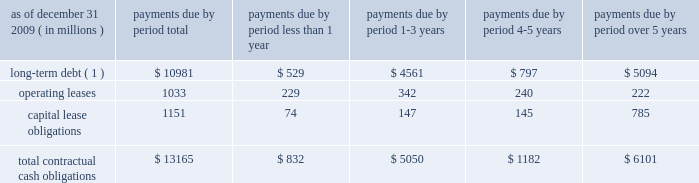We currently maintain a corporate commercial paper program , unrelated to the conduits 2019 asset-backed commercial paper program , under which we can issue up to $ 3 billion with original maturities of up to 270 days from the date of issue .
At december 31 , 2009 , we had $ 2.78 billion of commercial paper outstanding , compared to $ 2.59 billion at december 31 , 2008 .
Additional information about our corporate commercial paper program is provided in note 8 of the notes to consolidated financial statements included under item 8 .
In connection with our participation in the fdic 2019s temporary liquidity guarantee program , or tlgp , in which we elected to participate in december 2008 , the parent company was eligible to issue up to approximately $ 1.67 billion of unsecured senior debt during 2009 , backed by the full faith and credit of the united states .
As of december 31 , 2009 , the parent company 2019s outstanding unsecured senior debt issued under the tlgp was $ 1.5 billion .
Additional information with respect to this outstanding debt is provided in note 9 of the notes to consolidated financial statements included under item 8 .
The guarantee of this outstanding debt under the tlgp expires on april 30 , 2012 , the maturity date of the debt .
State street bank currently has board authority to issue bank notes up to an aggregate of $ 5 billion , and up to $ 1 billion of subordinated bank notes .
In connection with state street bank 2019s participation in the tlgp , in which state street bank elected to participate in december 2008 , state street bank was eligible to issue up to approximately $ 2.48 billion of unsecured senior notes during 2009 , backed by the full faith and credit of the united states .
As of december 31 , 2009 , state street bank 2019s outstanding unsecured senior notes issued under the tlgp , and pursuant to the aforementioned board authority , totaled $ 2.45 billion .
Additional information with respect to these outstanding bank notes is provided in note 9 of the notes to consolidated financial statements included under item 8 .
The guarantee of state street bank 2019s outstanding debt under the tlgp expires on the maturity date of each respective debt issuance , as follows 2014$ 1 billion on march 15 , 2011 , and $ 1.45 billion on september 15 , 2011 .
State street bank currently maintains a line of credit with a financial institution of cad $ 800 million , or approximately $ 761 million as of december 31 , 2009 , to support its canadian securities processing operations .
The line of credit has no stated termination date and is cancelable by either party with prior notice .
As of december 31 , 2009 , no balance was outstanding on this line of credit .
Contractual cash obligations .
( 1 ) long-term debt excludes capital lease obligations ( reported as a separate line item ) and the effect of interest- rate swaps .
Interest payments were calculated at the stated rate with the exception of floating-rate debt , for which payments were calculated using the indexed rate in effect on december 31 , 2009 .
The obligations presented in the table above are recorded in our consolidated statement of condition at december 31 , 2009 , except for interest on long-term debt .
The table does not include obligations which will be settled in cash , primarily in less than one year , such as deposits , federal funds purchased , securities sold under repurchase agreements and other short-term borrowings .
Additional information about deposits , federal funds purchased , securities sold under repurchase agreements and other short-term borrowings is provided in notes 7 and 8 of the notes to consolidated financial statements included under item 8 .
The table does not include obligations related to derivative instruments , because the amounts included in our consolidated statement of condition at december 31 , 2009 related to derivatives do not represent the amounts that may ultimately be paid under the contracts upon settlement .
Additional information about derivative contracts is provided in note 16 of the notes to consolidated financial statements included under item 8 .
We have obligations under pension and other post-retirement benefit plans , more fully described in note 18 of the notes to consolidated financial statements included under item 8 , which are not included in the above table. .
What percent of the total payments are due to be paid off within the first year? 
Computations: (832 / 13165)
Answer: 0.0632. We currently maintain a corporate commercial paper program , unrelated to the conduits 2019 asset-backed commercial paper program , under which we can issue up to $ 3 billion with original maturities of up to 270 days from the date of issue .
At december 31 , 2009 , we had $ 2.78 billion of commercial paper outstanding , compared to $ 2.59 billion at december 31 , 2008 .
Additional information about our corporate commercial paper program is provided in note 8 of the notes to consolidated financial statements included under item 8 .
In connection with our participation in the fdic 2019s temporary liquidity guarantee program , or tlgp , in which we elected to participate in december 2008 , the parent company was eligible to issue up to approximately $ 1.67 billion of unsecured senior debt during 2009 , backed by the full faith and credit of the united states .
As of december 31 , 2009 , the parent company 2019s outstanding unsecured senior debt issued under the tlgp was $ 1.5 billion .
Additional information with respect to this outstanding debt is provided in note 9 of the notes to consolidated financial statements included under item 8 .
The guarantee of this outstanding debt under the tlgp expires on april 30 , 2012 , the maturity date of the debt .
State street bank currently has board authority to issue bank notes up to an aggregate of $ 5 billion , and up to $ 1 billion of subordinated bank notes .
In connection with state street bank 2019s participation in the tlgp , in which state street bank elected to participate in december 2008 , state street bank was eligible to issue up to approximately $ 2.48 billion of unsecured senior notes during 2009 , backed by the full faith and credit of the united states .
As of december 31 , 2009 , state street bank 2019s outstanding unsecured senior notes issued under the tlgp , and pursuant to the aforementioned board authority , totaled $ 2.45 billion .
Additional information with respect to these outstanding bank notes is provided in note 9 of the notes to consolidated financial statements included under item 8 .
The guarantee of state street bank 2019s outstanding debt under the tlgp expires on the maturity date of each respective debt issuance , as follows 2014$ 1 billion on march 15 , 2011 , and $ 1.45 billion on september 15 , 2011 .
State street bank currently maintains a line of credit with a financial institution of cad $ 800 million , or approximately $ 761 million as of december 31 , 2009 , to support its canadian securities processing operations .
The line of credit has no stated termination date and is cancelable by either party with prior notice .
As of december 31 , 2009 , no balance was outstanding on this line of credit .
Contractual cash obligations .
( 1 ) long-term debt excludes capital lease obligations ( reported as a separate line item ) and the effect of interest- rate swaps .
Interest payments were calculated at the stated rate with the exception of floating-rate debt , for which payments were calculated using the indexed rate in effect on december 31 , 2009 .
The obligations presented in the table above are recorded in our consolidated statement of condition at december 31 , 2009 , except for interest on long-term debt .
The table does not include obligations which will be settled in cash , primarily in less than one year , such as deposits , federal funds purchased , securities sold under repurchase agreements and other short-term borrowings .
Additional information about deposits , federal funds purchased , securities sold under repurchase agreements and other short-term borrowings is provided in notes 7 and 8 of the notes to consolidated financial statements included under item 8 .
The table does not include obligations related to derivative instruments , because the amounts included in our consolidated statement of condition at december 31 , 2009 related to derivatives do not represent the amounts that may ultimately be paid under the contracts upon settlement .
Additional information about derivative contracts is provided in note 16 of the notes to consolidated financial statements included under item 8 .
We have obligations under pension and other post-retirement benefit plans , more fully described in note 18 of the notes to consolidated financial statements included under item 8 , which are not included in the above table. .
What percent of the total contractual cash obligations are from long term debt? 
Computations: (10981 / 13165)
Answer: 0.83411. We currently maintain a corporate commercial paper program , unrelated to the conduits 2019 asset-backed commercial paper program , under which we can issue up to $ 3 billion with original maturities of up to 270 days from the date of issue .
At december 31 , 2009 , we had $ 2.78 billion of commercial paper outstanding , compared to $ 2.59 billion at december 31 , 2008 .
Additional information about our corporate commercial paper program is provided in note 8 of the notes to consolidated financial statements included under item 8 .
In connection with our participation in the fdic 2019s temporary liquidity guarantee program , or tlgp , in which we elected to participate in december 2008 , the parent company was eligible to issue up to approximately $ 1.67 billion of unsecured senior debt during 2009 , backed by the full faith and credit of the united states .
As of december 31 , 2009 , the parent company 2019s outstanding unsecured senior debt issued under the tlgp was $ 1.5 billion .
Additional information with respect to this outstanding debt is provided in note 9 of the notes to consolidated financial statements included under item 8 .
The guarantee of this outstanding debt under the tlgp expires on april 30 , 2012 , the maturity date of the debt .
State street bank currently has board authority to issue bank notes up to an aggregate of $ 5 billion , and up to $ 1 billion of subordinated bank notes .
In connection with state street bank 2019s participation in the tlgp , in which state street bank elected to participate in december 2008 , state street bank was eligible to issue up to approximately $ 2.48 billion of unsecured senior notes during 2009 , backed by the full faith and credit of the united states .
As of december 31 , 2009 , state street bank 2019s outstanding unsecured senior notes issued under the tlgp , and pursuant to the aforementioned board authority , totaled $ 2.45 billion .
Additional information with respect to these outstanding bank notes is provided in note 9 of the notes to consolidated financial statements included under item 8 .
The guarantee of state street bank 2019s outstanding debt under the tlgp expires on the maturity date of each respective debt issuance , as follows 2014$ 1 billion on march 15 , 2011 , and $ 1.45 billion on september 15 , 2011 .
State street bank currently maintains a line of credit with a financial institution of cad $ 800 million , or approximately $ 761 million as of december 31 , 2009 , to support its canadian securities processing operations .
The line of credit has no stated termination date and is cancelable by either party with prior notice .
As of december 31 , 2009 , no balance was outstanding on this line of credit .
Contractual cash obligations .
( 1 ) long-term debt excludes capital lease obligations ( reported as a separate line item ) and the effect of interest- rate swaps .
Interest payments were calculated at the stated rate with the exception of floating-rate debt , for which payments were calculated using the indexed rate in effect on december 31 , 2009 .
The obligations presented in the table above are recorded in our consolidated statement of condition at december 31 , 2009 , except for interest on long-term debt .
The table does not include obligations which will be settled in cash , primarily in less than one year , such as deposits , federal funds purchased , securities sold under repurchase agreements and other short-term borrowings .
Additional information about deposits , federal funds purchased , securities sold under repurchase agreements and other short-term borrowings is provided in notes 7 and 8 of the notes to consolidated financial statements included under item 8 .
The table does not include obligations related to derivative instruments , because the amounts included in our consolidated statement of condition at december 31 , 2009 related to derivatives do not represent the amounts that may ultimately be paid under the contracts upon settlement .
Additional information about derivative contracts is provided in note 16 of the notes to consolidated financial statements included under item 8 .
We have obligations under pension and other post-retirement benefit plans , more fully described in note 18 of the notes to consolidated financial statements included under item 8 , which are not included in the above table. .
As of december 2009 what was the percent of the total contractual obligations that was due in less than 1 year for long-term debt ( 1 )? 
Computations: (529 / 10981)
Answer: 0.04817. 